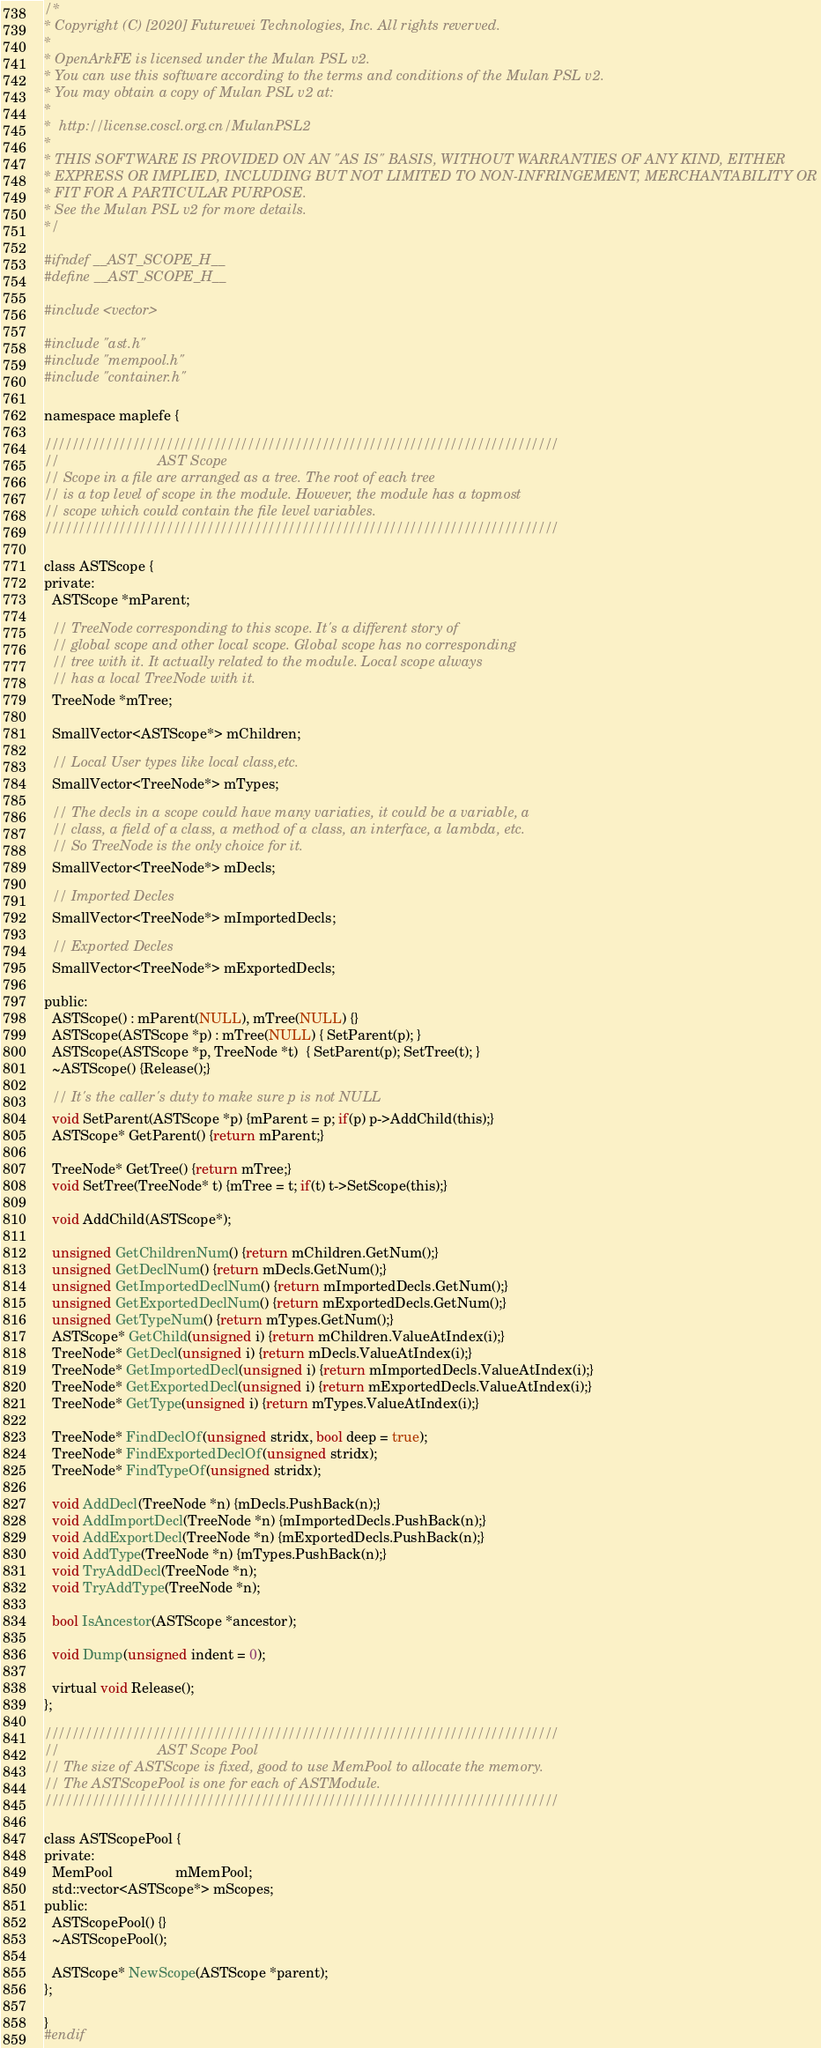<code> <loc_0><loc_0><loc_500><loc_500><_C_>/*
* Copyright (C) [2020] Futurewei Technologies, Inc. All rights reverved.
*
* OpenArkFE is licensed under the Mulan PSL v2.
* You can use this software according to the terms and conditions of the Mulan PSL v2.
* You may obtain a copy of Mulan PSL v2 at:
*
*  http://license.coscl.org.cn/MulanPSL2
*
* THIS SOFTWARE IS PROVIDED ON AN "AS IS" BASIS, WITHOUT WARRANTIES OF ANY KIND, EITHER
* EXPRESS OR IMPLIED, INCLUDING BUT NOT LIMITED TO NON-INFRINGEMENT, MERCHANTABILITY OR
* FIT FOR A PARTICULAR PURPOSE.
* See the Mulan PSL v2 for more details.
*/

#ifndef __AST_SCOPE_H__
#define __AST_SCOPE_H__

#include <vector>

#include "ast.h"
#include "mempool.h"
#include "container.h"

namespace maplefe {

////////////////////////////////////////////////////////////////////////////
//                         AST Scope
// Scope in a file are arranged as a tree. The root of each tree
// is a top level of scope in the module. However, the module has a topmost
// scope which could contain the file level variables.
////////////////////////////////////////////////////////////////////////////

class ASTScope {
private:
  ASTScope *mParent;

  // TreeNode corresponding to this scope. It's a different story of
  // global scope and other local scope. Global scope has no corresponding
  // tree with it. It actually related to the module. Local scope always
  // has a local TreeNode with it.
  TreeNode *mTree;

  SmallVector<ASTScope*> mChildren;

  // Local User types like local class,etc.
  SmallVector<TreeNode*> mTypes;

  // The decls in a scope could have many variaties, it could be a variable, a
  // class, a field of a class, a method of a class, an interface, a lambda, etc.
  // So TreeNode is the only choice for it.
  SmallVector<TreeNode*> mDecls;

  // Imported Decles
  SmallVector<TreeNode*> mImportedDecls;

  // Exported Decles
  SmallVector<TreeNode*> mExportedDecls;

public:
  ASTScope() : mParent(NULL), mTree(NULL) {}
  ASTScope(ASTScope *p) : mTree(NULL) { SetParent(p); }
  ASTScope(ASTScope *p, TreeNode *t)  { SetParent(p); SetTree(t); }
  ~ASTScope() {Release();}

  // It's the caller's duty to make sure p is not NULL
  void SetParent(ASTScope *p) {mParent = p; if(p) p->AddChild(this);}
  ASTScope* GetParent() {return mParent;}

  TreeNode* GetTree() {return mTree;}
  void SetTree(TreeNode* t) {mTree = t; if(t) t->SetScope(this);}

  void AddChild(ASTScope*);

  unsigned GetChildrenNum() {return mChildren.GetNum();}
  unsigned GetDeclNum() {return mDecls.GetNum();}
  unsigned GetImportedDeclNum() {return mImportedDecls.GetNum();}
  unsigned GetExportedDeclNum() {return mExportedDecls.GetNum();}
  unsigned GetTypeNum() {return mTypes.GetNum();}
  ASTScope* GetChild(unsigned i) {return mChildren.ValueAtIndex(i);}
  TreeNode* GetDecl(unsigned i) {return mDecls.ValueAtIndex(i);}
  TreeNode* GetImportedDecl(unsigned i) {return mImportedDecls.ValueAtIndex(i);}
  TreeNode* GetExportedDecl(unsigned i) {return mExportedDecls.ValueAtIndex(i);}
  TreeNode* GetType(unsigned i) {return mTypes.ValueAtIndex(i);}

  TreeNode* FindDeclOf(unsigned stridx, bool deep = true);
  TreeNode* FindExportedDeclOf(unsigned stridx);
  TreeNode* FindTypeOf(unsigned stridx);

  void AddDecl(TreeNode *n) {mDecls.PushBack(n);}
  void AddImportDecl(TreeNode *n) {mImportedDecls.PushBack(n);}
  void AddExportDecl(TreeNode *n) {mExportedDecls.PushBack(n);}
  void AddType(TreeNode *n) {mTypes.PushBack(n);}
  void TryAddDecl(TreeNode *n);
  void TryAddType(TreeNode *n);

  bool IsAncestor(ASTScope *ancestor);

  void Dump(unsigned indent = 0);

  virtual void Release();
};

////////////////////////////////////////////////////////////////////////////
//                         AST Scope Pool
// The size of ASTScope is fixed, good to use MemPool to allocate the memory.
// The ASTScopePool is one for each of ASTModule.
////////////////////////////////////////////////////////////////////////////

class ASTScopePool {
private:
  MemPool                mMemPool;
  std::vector<ASTScope*> mScopes;
public:
  ASTScopePool() {}
  ~ASTScopePool();

  ASTScope* NewScope(ASTScope *parent);
};

}
#endif
</code> 